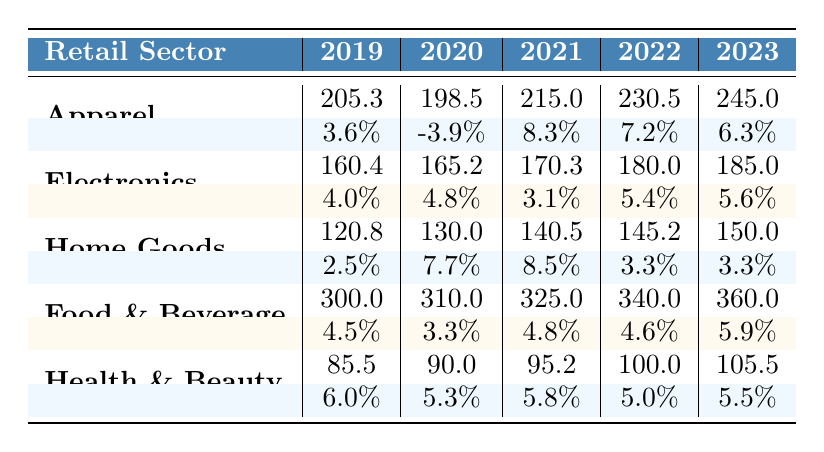What was the spending in the Apparel sector in 2021? According to the table, the spending in the Apparel sector for 2021 is listed directly under that category, which is 215.0.
Answer: 215.0 What was the growth rate for Electronics in 2022? The growth rate for Electronics in 2022 is provided in the table under that year's column, which is found to be 5.4%.
Answer: 5.4% Which retail sector had the highest spending in 2023? By comparing the 2023 spending values from all sectors, Food and Beverage has the highest spending of 360.0.
Answer: Food and Beverage What is the total spending across all sectors for the year 2020? To find the total spending for 2020, sum the spending of each sector: 198.5 (Apparel) + 165.2 (Electronics) + 130.0 (HomeGoods) + 310.0 (Food and Beverage) + 90.0 (Health and Beauty) = 893.7.
Answer: 893.7 Did the spending in HomeGoods decline in 2020 compared to 2019? The spending for HomeGoods in 2019 is 120.8, while in 2020 it is 130.0. Since 130.0 is higher than 120.8, the spending did not decline.
Answer: No What is the average growth rate for Health and Beauty over the five years? Calculate the average growth rate: (6.0 + 5.3 + 5.8 + 5.0 + 5.5) / 5 = 5.52. Thus, the average growth rate for Health and Beauty is 5.52%.
Answer: 5.52% Which two sectors experienced a negative growth rate during the analyzed years? Check each sector's growth rates; Apparel had a negative growth rate of -3.9% in 2020, while there were no other negative growth rates in the other sectors. Thus, only Apparel experienced a negative growth rate.
Answer: Apparel How much did spending in Food and Beverage increase from 2019 to 2023? The spending in Food and Beverage for 2019 is 300.0, and for 2023 is 360.0. The increase is calculated as 360.0 - 300.0 = 60.0.
Answer: 60.0 In which year did the Apparel sector see the highest growth rate? Check the growth rates for Apparel: 3.6% in 2019, -3.9% in 2020, 8.3% in 2021, 7.2% in 2022, and 6.3% in 2023. The highest growth rate of 8.3% occurred in 2021.
Answer: 2021 